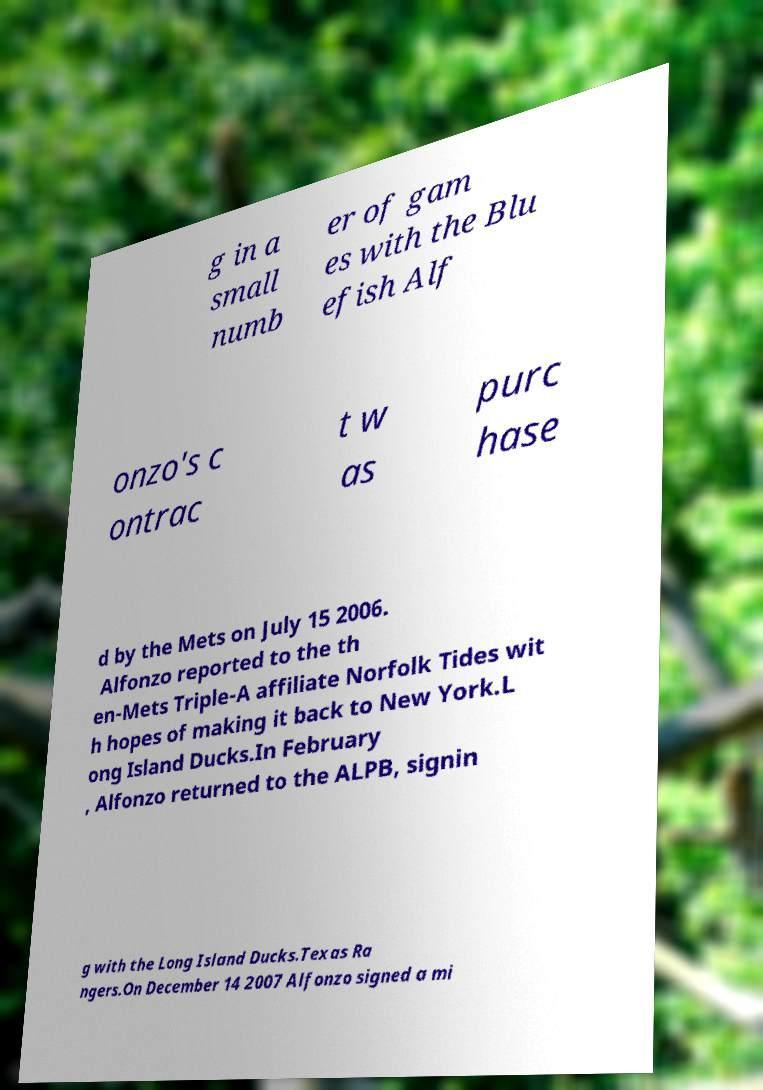Please identify and transcribe the text found in this image. g in a small numb er of gam es with the Blu efish Alf onzo's c ontrac t w as purc hase d by the Mets on July 15 2006. Alfonzo reported to the th en-Mets Triple-A affiliate Norfolk Tides wit h hopes of making it back to New York.L ong Island Ducks.In February , Alfonzo returned to the ALPB, signin g with the Long Island Ducks.Texas Ra ngers.On December 14 2007 Alfonzo signed a mi 